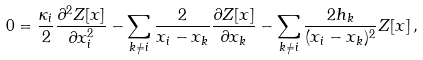<formula> <loc_0><loc_0><loc_500><loc_500>0 = \frac { \kappa _ { i } } { 2 } \frac { \partial ^ { 2 } Z [ x ] } { \partial x _ { i } ^ { 2 } } - \sum _ { k \ne i } \frac { 2 } { x _ { i } - x _ { k } } \frac { \partial Z [ x ] } { \partial x _ { k } } - \sum _ { k \ne i } \frac { 2 h _ { k } } { ( x _ { i } - x _ { k } ) ^ { 2 } } Z [ x ] \, ,</formula> 